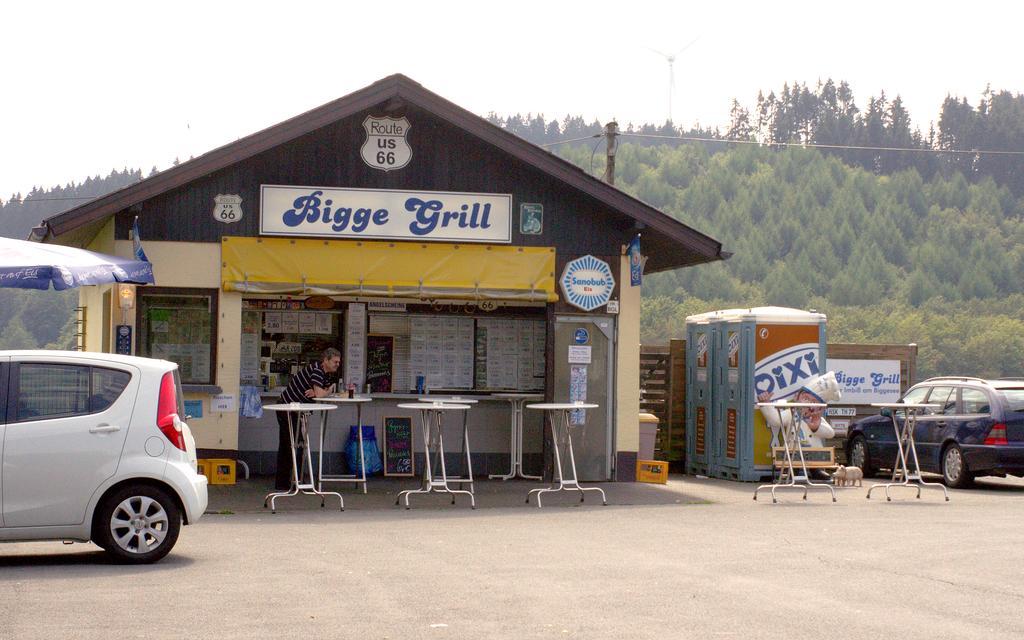Describe this image in one or two sentences. In the center of the image there is a shed and there are tables. We can see a man standing. At the bottom there are cars. In the background there is a tent and a booth. There are trees we can see a pole. At the top there is sky. 